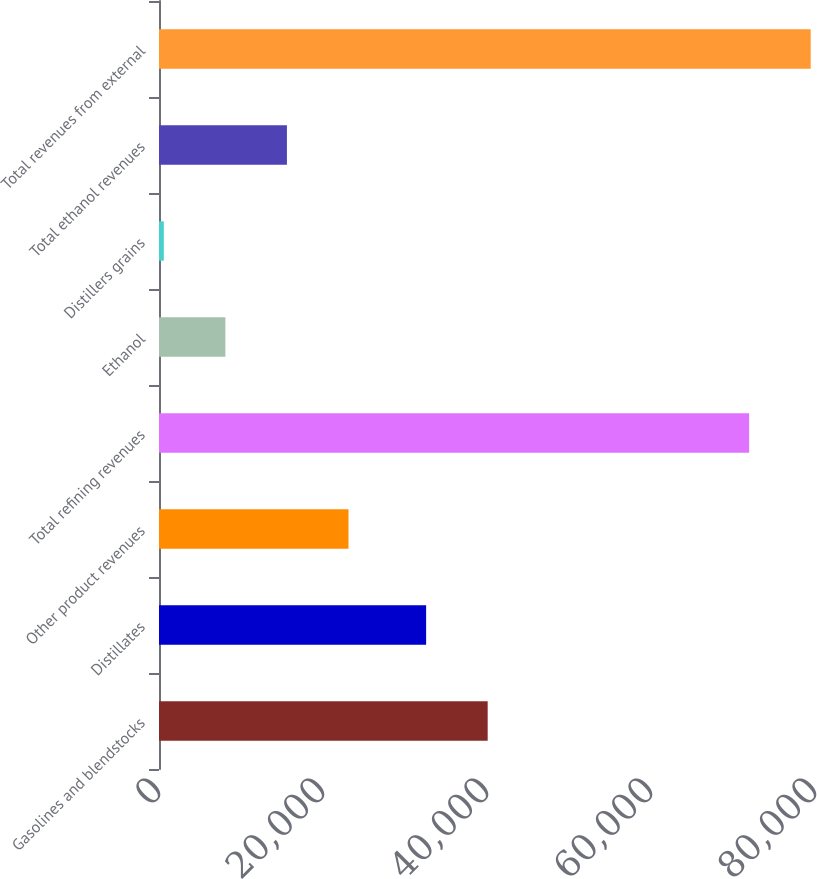Convert chart. <chart><loc_0><loc_0><loc_500><loc_500><bar_chart><fcel>Gasolines and blendstocks<fcel>Distillates<fcel>Other product revenues<fcel>Total refining revenues<fcel>Ethanol<fcel>Distillers grains<fcel>Total ethanol revenues<fcel>Total revenues from external<nl><fcel>40083.3<fcel>32576<fcel>23107.9<fcel>71968<fcel>8093.3<fcel>586<fcel>15600.6<fcel>79475.3<nl></chart> 